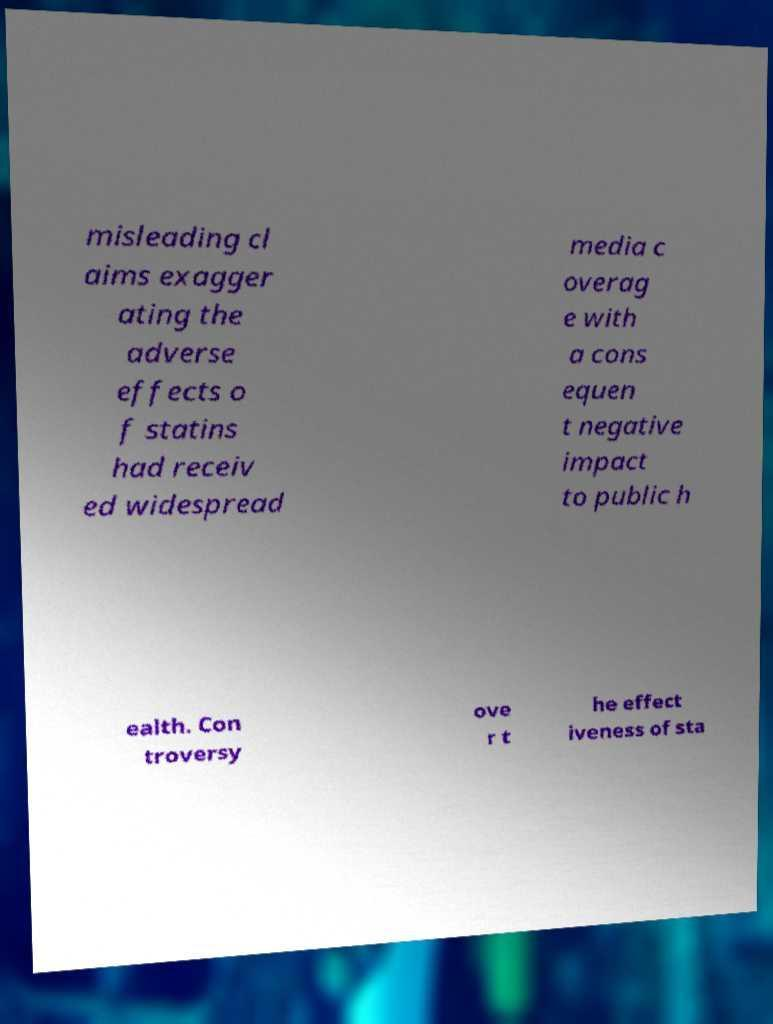What messages or text are displayed in this image? I need them in a readable, typed format. misleading cl aims exagger ating the adverse effects o f statins had receiv ed widespread media c overag e with a cons equen t negative impact to public h ealth. Con troversy ove r t he effect iveness of sta 